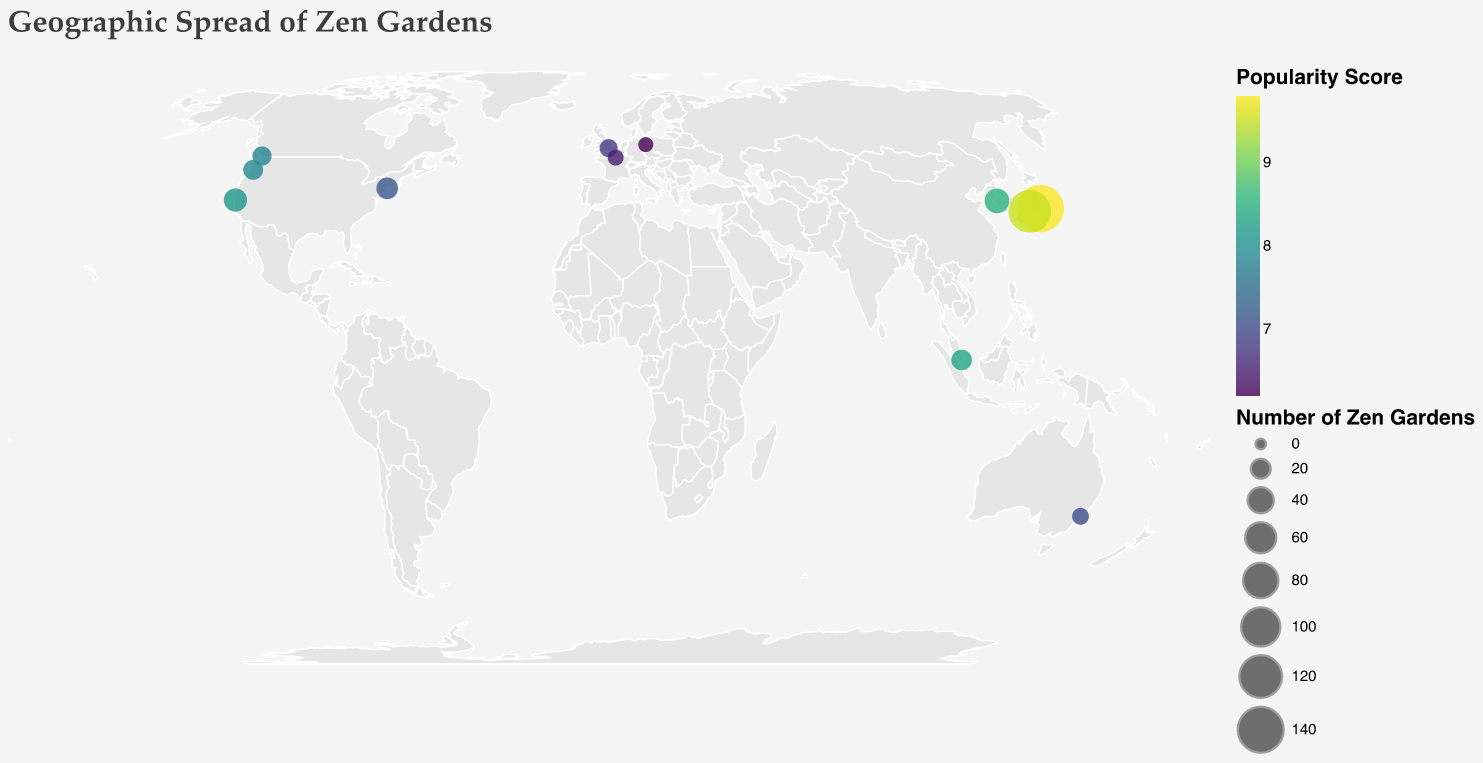Which city has the highest number of Zen gardens? By interpreting the circle sizes on the map, Tokyo has the largest circle, indicating the highest number of Zen gardens.
Answer: Tokyo What is the most popular city for Zen gardens outside Japan? By comparing the popularity scores of cities outside Japan, Seoul in South Korea has the highest score of 8.5.
Answer: Seoul How many cities in the USA are represented on the map? From the tooltip information and locations on the map, three cities are shown in the USA: New York City, San Francisco, and Portland.
Answer: 3 Which city has the lowest popularity score for Zen gardens? By looking at the colors representing popularity scores, Berlin has the lightest color, indicating the lowest score of 6.2.
Answer: Berlin How many Zen gardens are there in Europe according to the figure? Adding the number of Zen gardens in European cities: London (15), Paris (10), and Berlin (8) gives 15 + 10 + 8 = 33.
Answer: 33 Which city has a higher popularity score, Portland or Singapore? Checking the colors on the map for both cities, Singapore has a darker color (8.3) compared to Portland (7.9).
Answer: Singapore What is the combined number of Zen gardens in Kyoto and Tokyo? Adding the number from Kyoto (120) and Tokyo (150) gives 120 + 150 = 270.
Answer: 270 Which city has more Zen gardens, San Francisco or Sydney? Comparing the circle sizes on the map, San Francisco has 30 while Sydney has 12 Zen gardens.
Answer: San Francisco Which country has the highest number of cities represented in the figure? The USA has three cities: New York City, San Francisco, and Portland, which is more than any other country.
Answer: USA What's the average popularity score of cities in the USA? Taking the popularity scores from New York City (7.2), San Francisco (8.1), and Portland (7.9), the average is (7.2 + 8.1 + 7.9) / 3 = 7.7
Answer: 7.7 